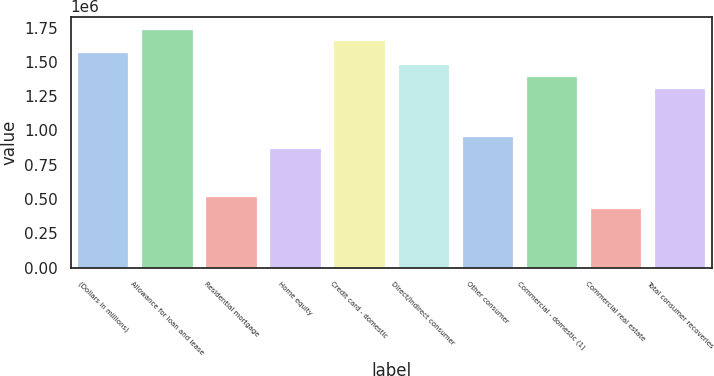Convert chart to OTSL. <chart><loc_0><loc_0><loc_500><loc_500><bar_chart><fcel>(Dollars in millions)<fcel>Allowance for loan and lease<fcel>Residential mortgage<fcel>Home equity<fcel>Credit card - domestic<fcel>Direct/Indirect consumer<fcel>Other consumer<fcel>Commercial - domestic (1)<fcel>Commercial real estate<fcel>Total consumer recoveries<nl><fcel>1.56916e+06<fcel>1.74351e+06<fcel>523053<fcel>871754<fcel>1.65633e+06<fcel>1.48198e+06<fcel>958929<fcel>1.39481e+06<fcel>435877<fcel>1.30763e+06<nl></chart> 